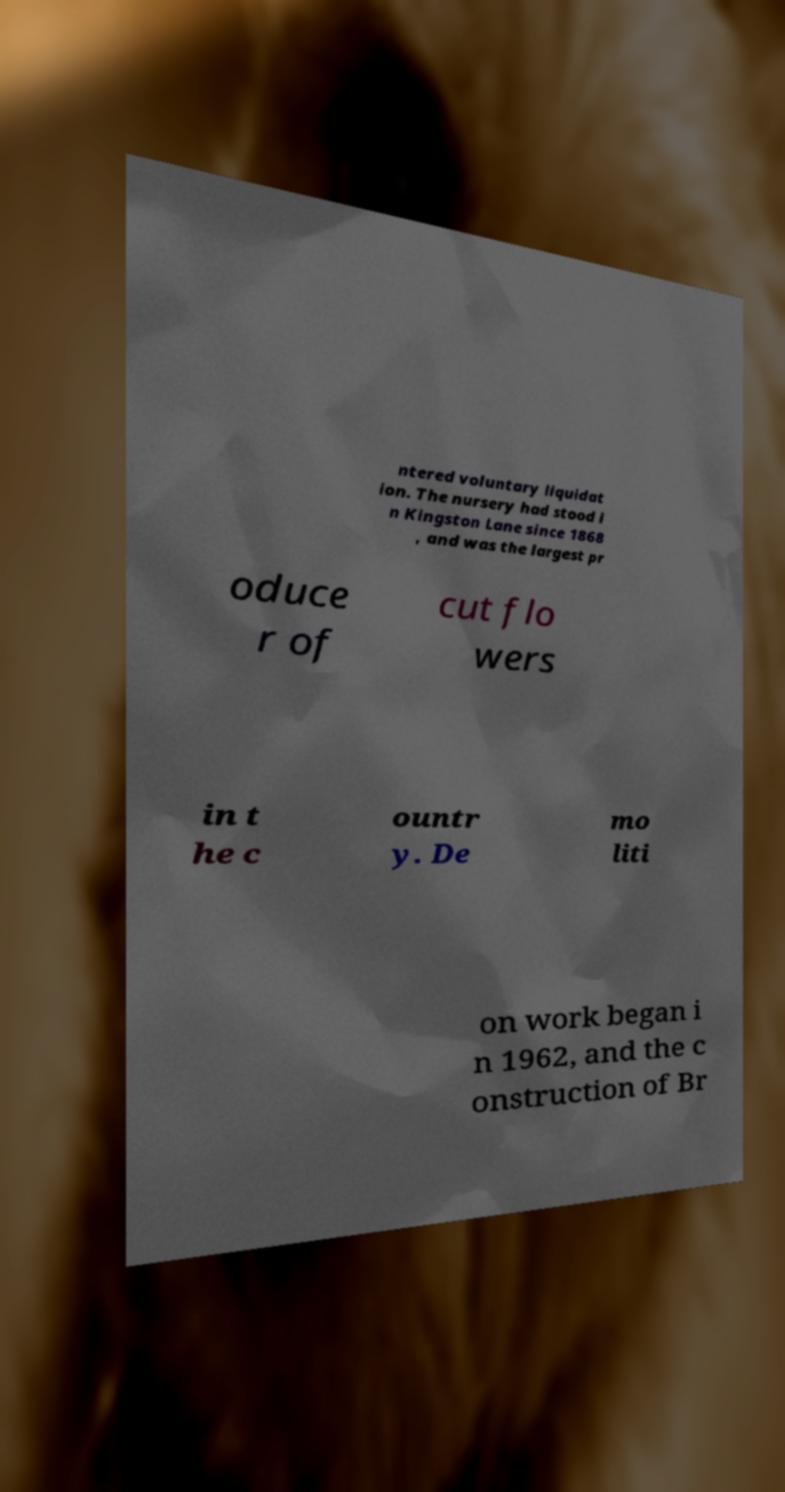For documentation purposes, I need the text within this image transcribed. Could you provide that? ntered voluntary liquidat ion. The nursery had stood i n Kingston Lane since 1868 , and was the largest pr oduce r of cut flo wers in t he c ountr y. De mo liti on work began i n 1962, and the c onstruction of Br 